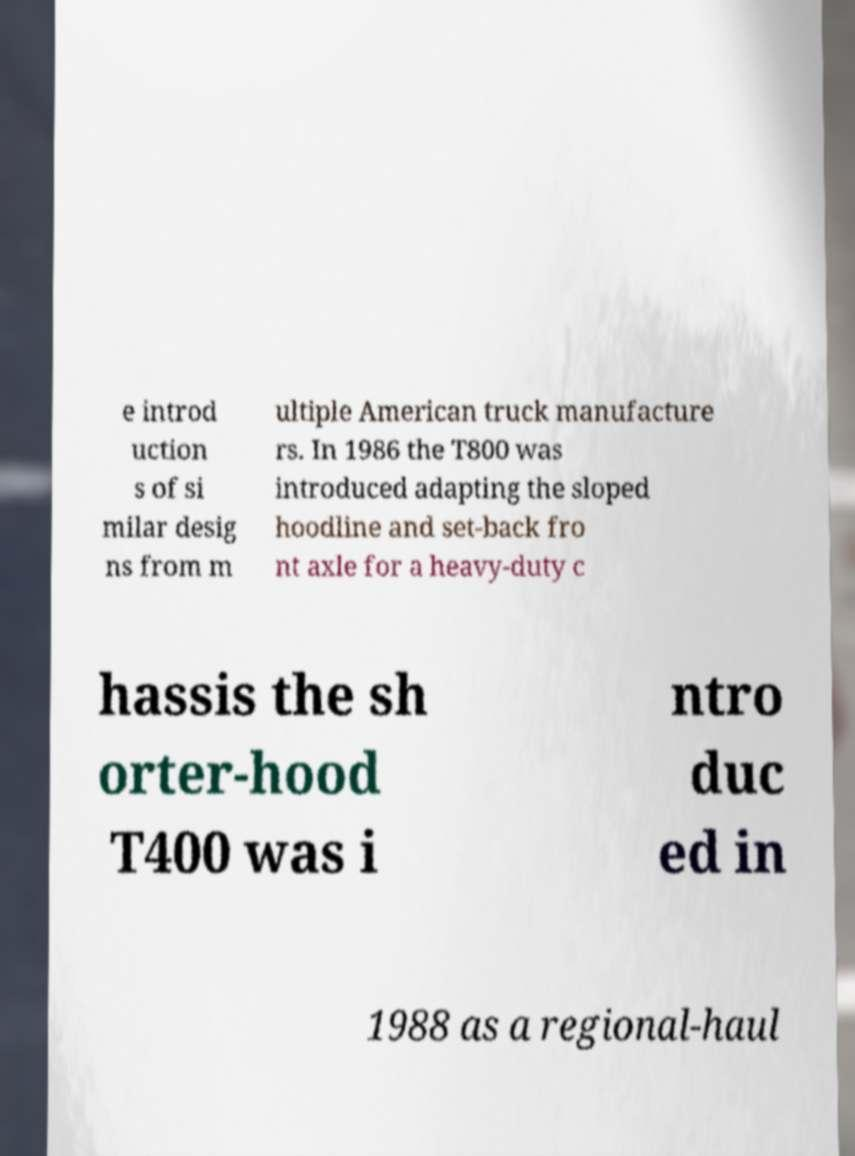Please read and relay the text visible in this image. What does it say? e introd uction s of si milar desig ns from m ultiple American truck manufacture rs. In 1986 the T800 was introduced adapting the sloped hoodline and set-back fro nt axle for a heavy-duty c hassis the sh orter-hood T400 was i ntro duc ed in 1988 as a regional-haul 